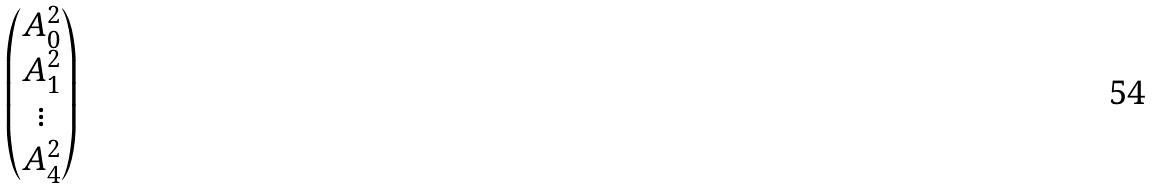Convert formula to latex. <formula><loc_0><loc_0><loc_500><loc_500>\begin{pmatrix} A _ { 0 } ^ { 2 } \\ A _ { 1 } ^ { 2 } \\ \vdots \\ A _ { 4 } ^ { 2 } \end{pmatrix}</formula> 